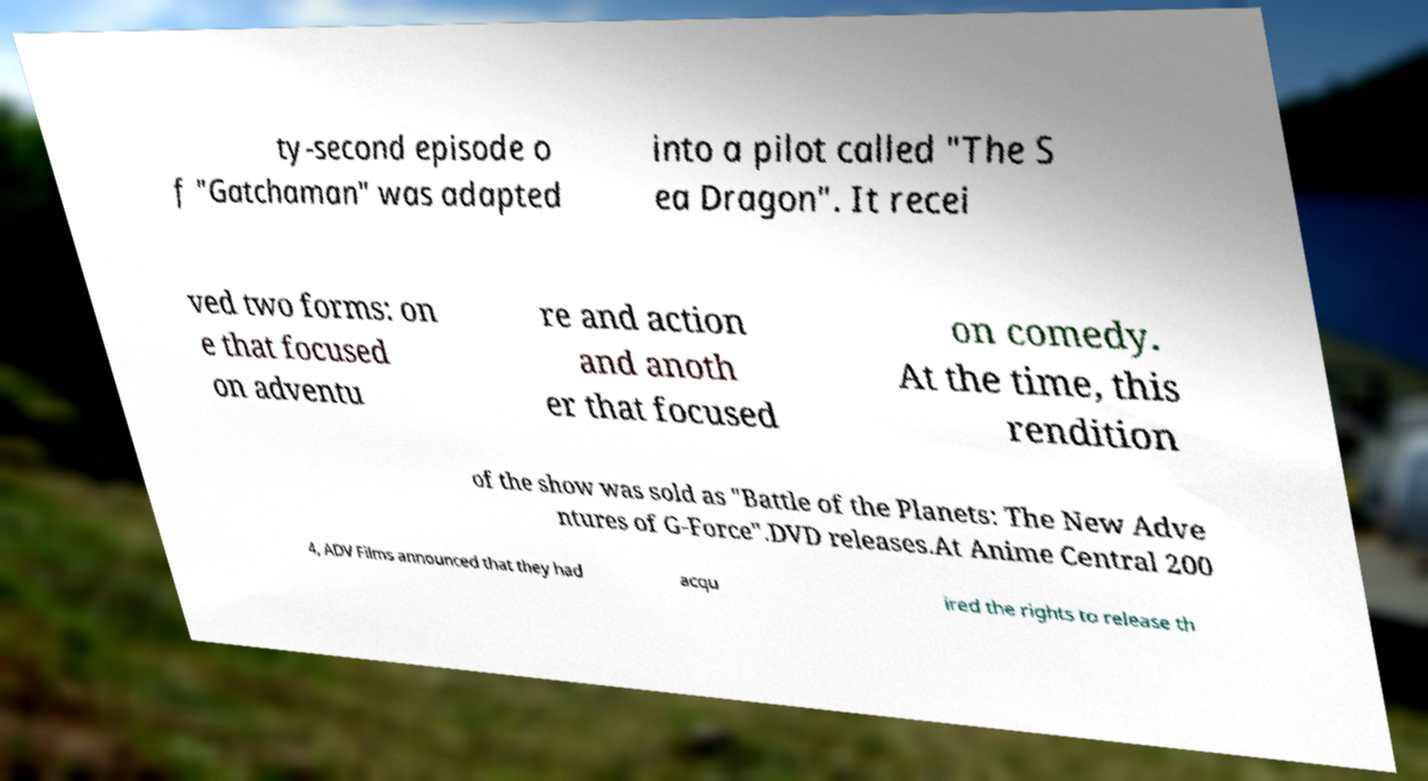Could you assist in decoding the text presented in this image and type it out clearly? ty-second episode o f "Gatchaman" was adapted into a pilot called "The S ea Dragon". It recei ved two forms: on e that focused on adventu re and action and anoth er that focused on comedy. At the time, this rendition of the show was sold as "Battle of the Planets: The New Adve ntures of G-Force".DVD releases.At Anime Central 200 4, ADV Films announced that they had acqu ired the rights to release th 